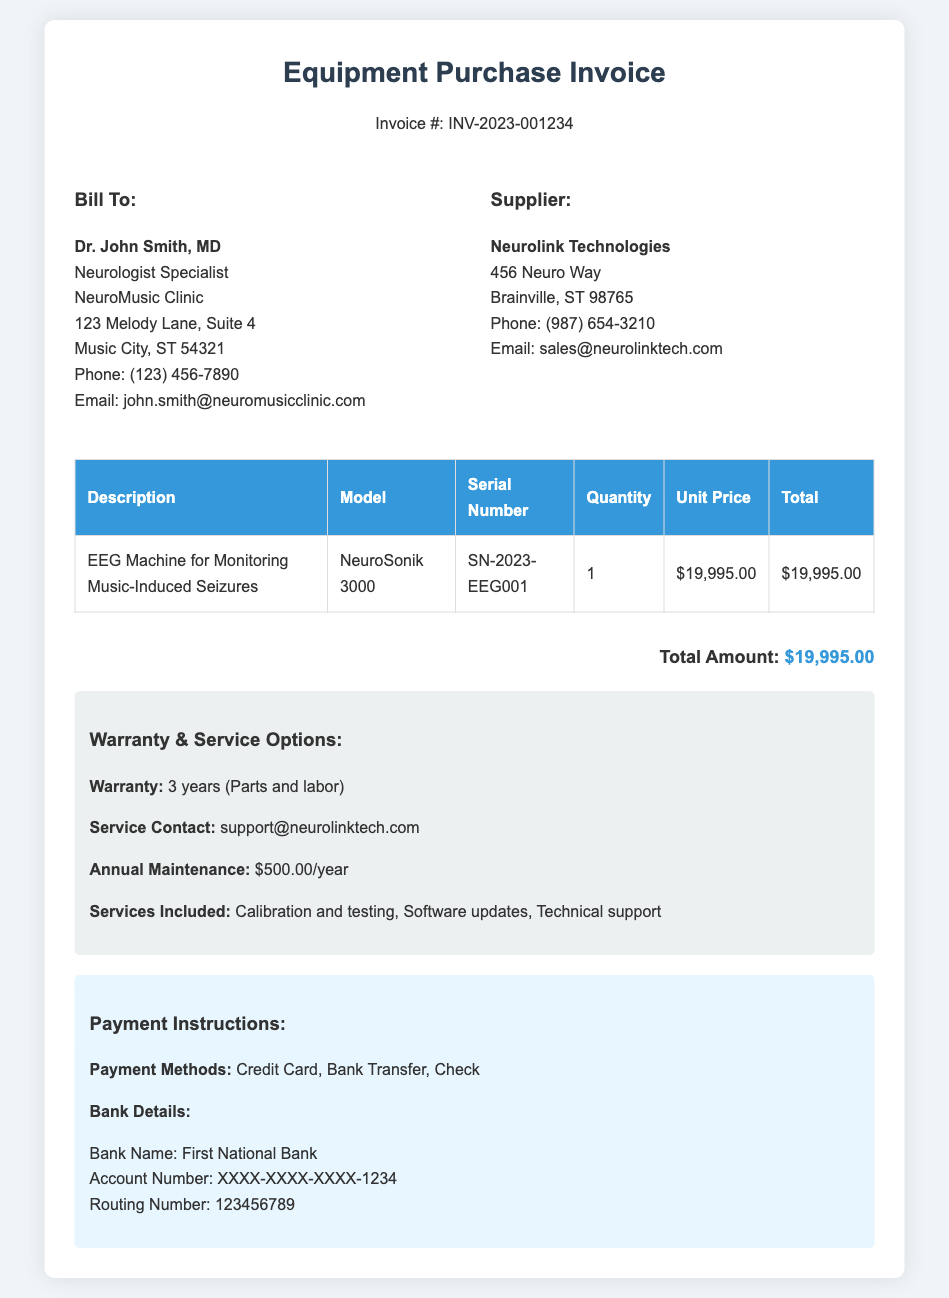What is the invoice number? The invoice number is displayed prominently at the top of the document.
Answer: INV-2023-001234 Who is the supplier? The supplier's information is listed in the invoice details section.
Answer: Neurolink Technologies What is the model of the EEG machine? The model is provided in the table detailing the equipment purchased.
Answer: NeuroSonik 3000 What is the total amount of the invoice? The total amount is summarized at the bottom of the invoice.
Answer: $19,995.00 How long is the warranty for the EEG machine? The warranty information is provided in the terms section of the document.
Answer: 3 years What services are included with the machine's service options? The services included are detailed in the terms section of the invoice.
Answer: Calibration and testing, Software updates, Technical support What is the annual maintenance cost? The annual maintenance cost is specified in the warranty and service options section.
Answer: $500.00/year What payment methods are accepted? The payment methods are outlined in the payment instructions section.
Answer: Credit Card, Bank Transfer, Check What is the serial number for the EEG machine? The serial number can be found in the equipment details table.
Answer: SN-2023-EEG001 